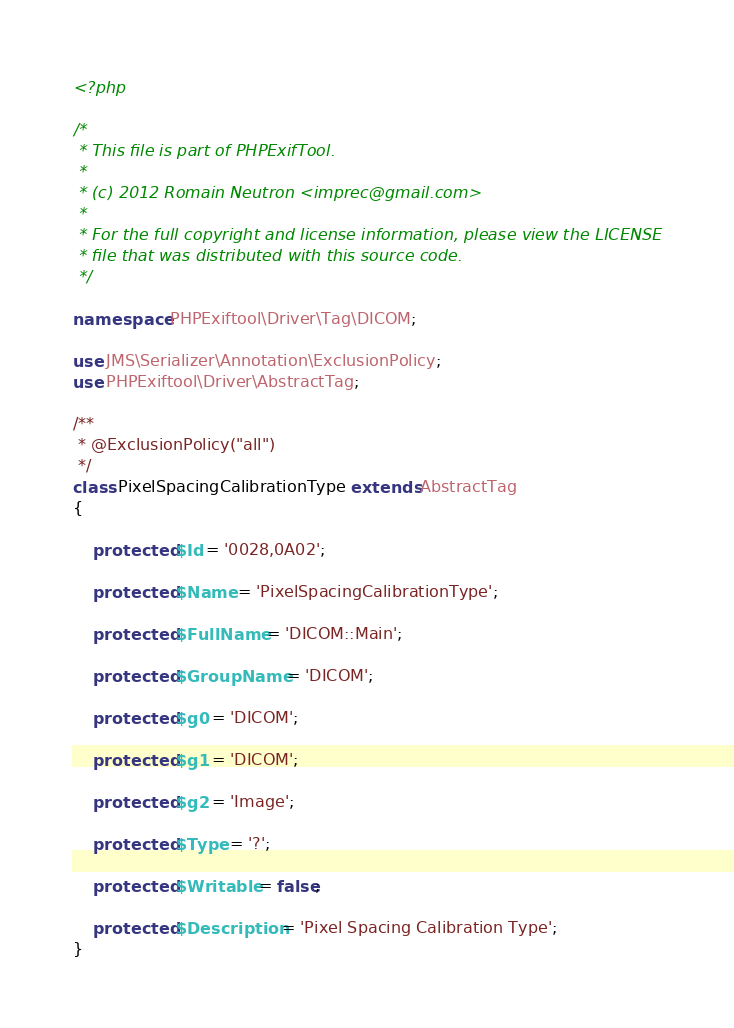<code> <loc_0><loc_0><loc_500><loc_500><_PHP_><?php

/*
 * This file is part of PHPExifTool.
 *
 * (c) 2012 Romain Neutron <imprec@gmail.com>
 *
 * For the full copyright and license information, please view the LICENSE
 * file that was distributed with this source code.
 */

namespace PHPExiftool\Driver\Tag\DICOM;

use JMS\Serializer\Annotation\ExclusionPolicy;
use PHPExiftool\Driver\AbstractTag;

/**
 * @ExclusionPolicy("all")
 */
class PixelSpacingCalibrationType extends AbstractTag
{

    protected $Id = '0028,0A02';

    protected $Name = 'PixelSpacingCalibrationType';

    protected $FullName = 'DICOM::Main';

    protected $GroupName = 'DICOM';

    protected $g0 = 'DICOM';

    protected $g1 = 'DICOM';

    protected $g2 = 'Image';

    protected $Type = '?';

    protected $Writable = false;

    protected $Description = 'Pixel Spacing Calibration Type';
}
</code> 